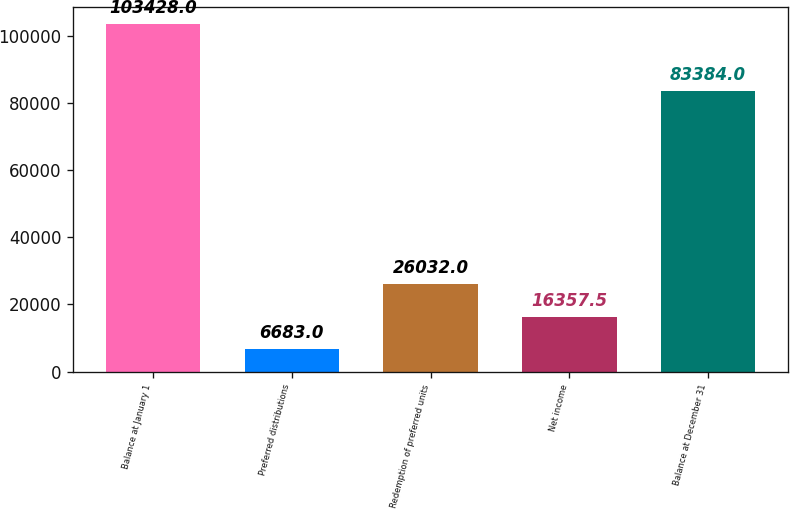Convert chart to OTSL. <chart><loc_0><loc_0><loc_500><loc_500><bar_chart><fcel>Balance at January 1<fcel>Preferred distributions<fcel>Redemption of preferred units<fcel>Net income<fcel>Balance at December 31<nl><fcel>103428<fcel>6683<fcel>26032<fcel>16357.5<fcel>83384<nl></chart> 